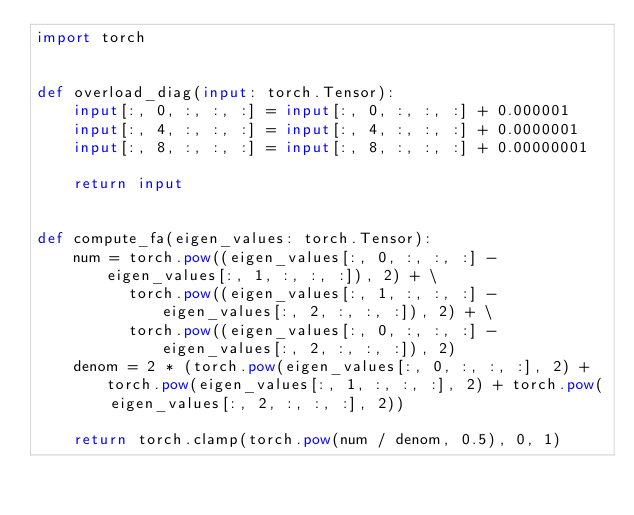Convert code to text. <code><loc_0><loc_0><loc_500><loc_500><_Python_>import torch


def overload_diag(input: torch.Tensor):
    input[:, 0, :, :, :] = input[:, 0, :, :, :] + 0.000001
    input[:, 4, :, :, :] = input[:, 4, :, :, :] + 0.0000001
    input[:, 8, :, :, :] = input[:, 8, :, :, :] + 0.00000001

    return input


def compute_fa(eigen_values: torch.Tensor):
    num = torch.pow((eigen_values[:, 0, :, :, :] - eigen_values[:, 1, :, :, :]), 2) + \
          torch.pow((eigen_values[:, 1, :, :, :] - eigen_values[:, 2, :, :, :]), 2) + \
          torch.pow((eigen_values[:, 0, :, :, :] - eigen_values[:, 2, :, :, :]), 2)
    denom = 2 * (torch.pow(eigen_values[:, 0, :, :, :], 2) + torch.pow(eigen_values[:, 1, :, :, :], 2) + torch.pow(
        eigen_values[:, 2, :, :, :], 2))

    return torch.clamp(torch.pow(num / denom, 0.5), 0, 1)</code> 